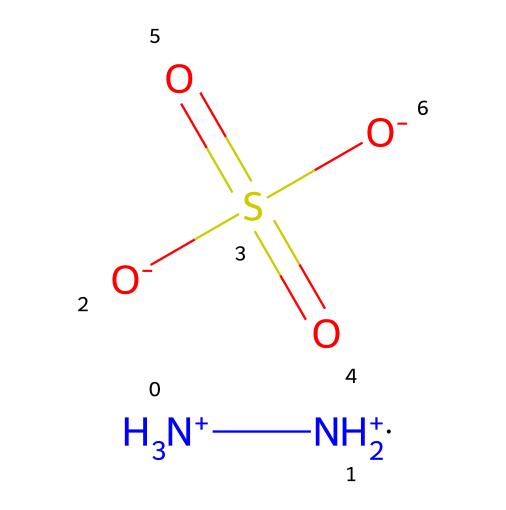What is the molecular formula of hydrazine sulfate? By analyzing the provided SMILES representation, we note the components: two nitrogen atoms (NH2+ and NH3+), four hydrogen atoms (two from NH2+ and three from NH3+), one sulfur atom (S), and four oxygen atoms (O). The total counts give us the molecular formula: N2H8O4S.
Answer: N2H8O4S How many nitrogen atoms are present in hydrazine sulfate? The SMILES representation shows two nitrogen symbols (N) at the beginning. Thus, counting them, we find that there are two nitrogen atoms.
Answer: 2 What is the charge of hydrazine sulfate? The provided SMILES indicates that the hydrazine moieties are positively charged ([NH3+] and [NH2+]), while the sulfate part has two negatively charged oxygen symbols ([O-] and [O-]). Adding these together results in a net charge of zero.
Answer: neutral Which functional groups are present in hydrazine sulfate? From the SMILES, we can identify the presence of amine functional groups (from the nitrogen atoms) and a sulfate functional group (from the sulfur atom bonded to the oxygen atoms). Therefore, amine and sulfate groups are present.
Answer: amine and sulfate Can hydrazine sulfate be used as a performance enhancer in motorsports? Given the characteristics of hydrazine compounds, they have been associated with energy enhancement. However, they also pose significant health risks. Understanding these factors allows us to evaluate its potential in motorsports properly.
Answer: Yes, but risky How many oxygen atoms are present in hydrazine sulfate? The SMILES illustrates that there are four oxygens represented as [O]. Counting each [O] shows a total of four oxygen atoms in the compound.
Answer: 4 What type of chemical is hydrazine sulfate categorized as? Hydrazine sulfate consists primarily of hydrazine derivatives along with a sulfate group, categorizing it as a hydrazine and oxyacid derivative. This classification relates to its nitrogen and sulfur components.
Answer: hydrazine derivative 